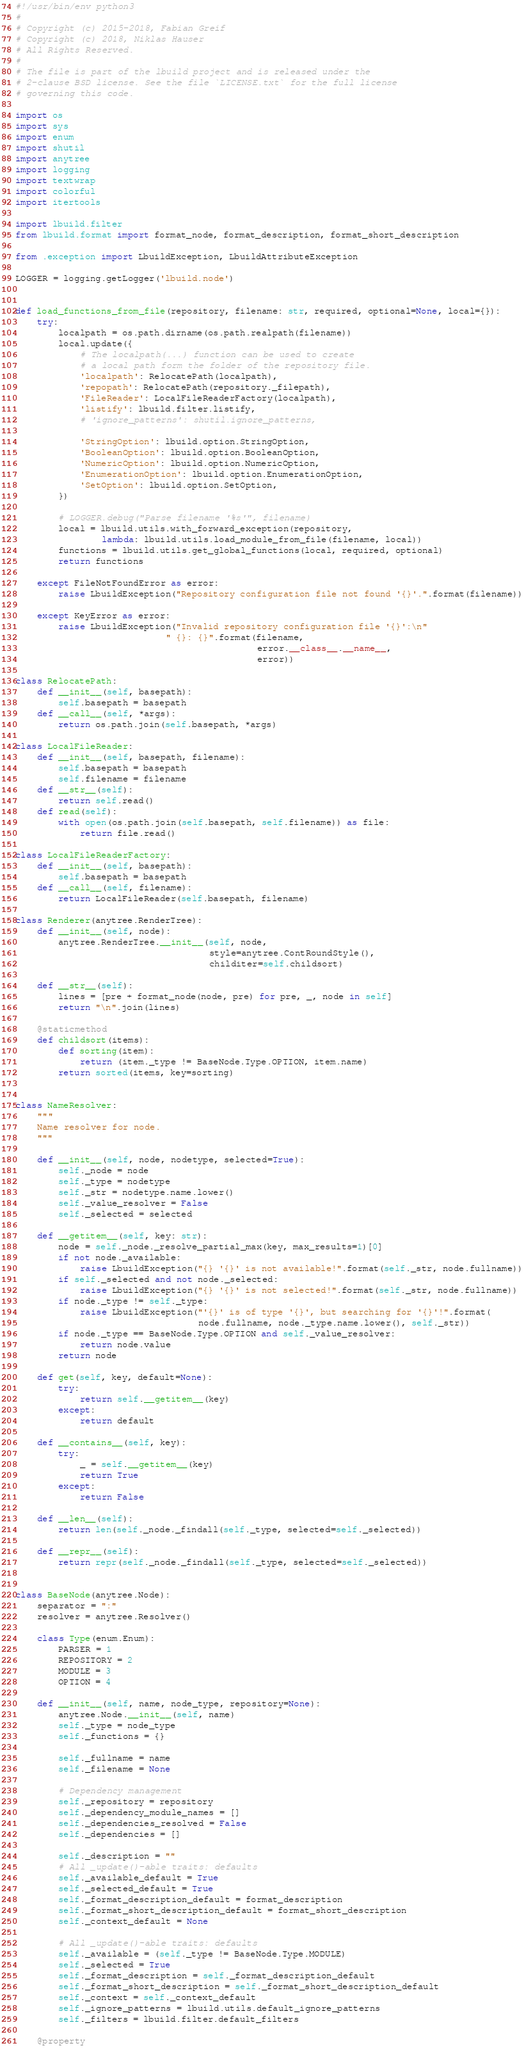Convert code to text. <code><loc_0><loc_0><loc_500><loc_500><_Python_>
#!/usr/bin/env python3
#
# Copyright (c) 2015-2018, Fabian Greif
# Copyright (c) 2018, Niklas Hauser
# All Rights Reserved.
#
# The file is part of the lbuild project and is released under the
# 2-clause BSD license. See the file `LICENSE.txt` for the full license
# governing this code.

import os
import sys
import enum
import shutil
import anytree
import logging
import textwrap
import colorful
import itertools

import lbuild.filter
from lbuild.format import format_node, format_description, format_short_description

from .exception import LbuildException, LbuildAttributeException

LOGGER = logging.getLogger('lbuild.node')


def load_functions_from_file(repository, filename: str, required, optional=None, local={}):
    try:
        localpath = os.path.dirname(os.path.realpath(filename))
        local.update({
            # The localpath(...) function can be used to create
            # a local path form the folder of the repository file.
            'localpath': RelocatePath(localpath),
            'repopath': RelocatePath(repository._filepath),
            'FileReader': LocalFileReaderFactory(localpath),
            'listify': lbuild.filter.listify,
            # 'ignore_patterns': shutil.ignore_patterns,

            'StringOption': lbuild.option.StringOption,
            'BooleanOption': lbuild.option.BooleanOption,
            'NumericOption': lbuild.option.NumericOption,
            'EnumerationOption': lbuild.option.EnumerationOption,
            'SetOption': lbuild.option.SetOption,
        })

        # LOGGER.debug("Parse filename '%s'", filename)
        local = lbuild.utils.with_forward_exception(repository,
                lambda: lbuild.utils.load_module_from_file(filename, local))
        functions = lbuild.utils.get_global_functions(local, required, optional)
        return functions

    except FileNotFoundError as error:
        raise LbuildException("Repository configuration file not found '{}'.".format(filename))

    except KeyError as error:
        raise LbuildException("Invalid repository configuration file '{}':\n"
                            " {}: {}".format(filename,
                                             error.__class__.__name__,
                                             error))

class RelocatePath:
    def __init__(self, basepath):
        self.basepath = basepath
    def __call__(self, *args):
        return os.path.join(self.basepath, *args)

class LocalFileReader:
    def __init__(self, basepath, filename):
        self.basepath = basepath
        self.filename = filename
    def __str__(self):
        return self.read()
    def read(self):
        with open(os.path.join(self.basepath, self.filename)) as file:
            return file.read()

class LocalFileReaderFactory:
    def __init__(self, basepath):
        self.basepath = basepath
    def __call__(self, filename):
        return LocalFileReader(self.basepath, filename)

class Renderer(anytree.RenderTree):
    def __init__(self, node):
        anytree.RenderTree.__init__(self, node,
                                    style=anytree.ContRoundStyle(),
                                    childiter=self.childsort)

    def __str__(self):
        lines = [pre + format_node(node, pre) for pre, _, node in self]
        return "\n".join(lines)

    @staticmethod
    def childsort(items):
        def sorting(item):
            return (item._type != BaseNode.Type.OPTION, item.name)
        return sorted(items, key=sorting)


class NameResolver:
    """
    Name resolver for node.
    """

    def __init__(self, node, nodetype, selected=True):
        self._node = node
        self._type = nodetype
        self._str = nodetype.name.lower()
        self._value_resolver = False
        self._selected = selected

    def __getitem__(self, key: str):
        node = self._node._resolve_partial_max(key, max_results=1)[0]
        if not node._available:
            raise LbuildException("{} '{}' is not available!".format(self._str, node.fullname))
        if self._selected and not node._selected:
            raise LbuildException("{} '{}' is not selected!".format(self._str, node.fullname))
        if node._type != self._type:
            raise LbuildException("'{}' is of type '{}', but searching for '{}'!".format(
                                  node.fullname, node._type.name.lower(), self._str))
        if node._type == BaseNode.Type.OPTION and self._value_resolver:
            return node.value
        return node

    def get(self, key, default=None):
        try:
            return self.__getitem__(key)
        except:
            return default

    def __contains__(self, key):
        try:
            _ = self.__getitem__(key)
            return True
        except:
            return False

    def __len__(self):
        return len(self._node._findall(self._type, selected=self._selected))

    def __repr__(self):
        return repr(self._node._findall(self._type, selected=self._selected))


class BaseNode(anytree.Node):
    separator = ":"
    resolver = anytree.Resolver()

    class Type(enum.Enum):
        PARSER = 1
        REPOSITORY = 2
        MODULE = 3
        OPTION = 4

    def __init__(self, name, node_type, repository=None):
        anytree.Node.__init__(self, name)
        self._type = node_type
        self._functions = {}

        self._fullname = name
        self._filename = None

        # Dependency management
        self._repository = repository
        self._dependency_module_names = []
        self._dependencies_resolved = False
        self._dependencies = []

        self._description = ""
        # All _update()-able traits: defaults
        self._available_default = True
        self._selected_default = True
        self._format_description_default = format_description
        self._format_short_description_default = format_short_description
        self._context_default = None

        # All _update()-able traits: defaults
        self._available = (self._type != BaseNode.Type.MODULE)
        self._selected = True
        self._format_description = self._format_description_default
        self._format_short_description = self._format_short_description_default
        self._context = self._context_default
        self._ignore_patterns = lbuild.utils.default_ignore_patterns
        self._filters = lbuild.filter.default_filters

    @property</code> 